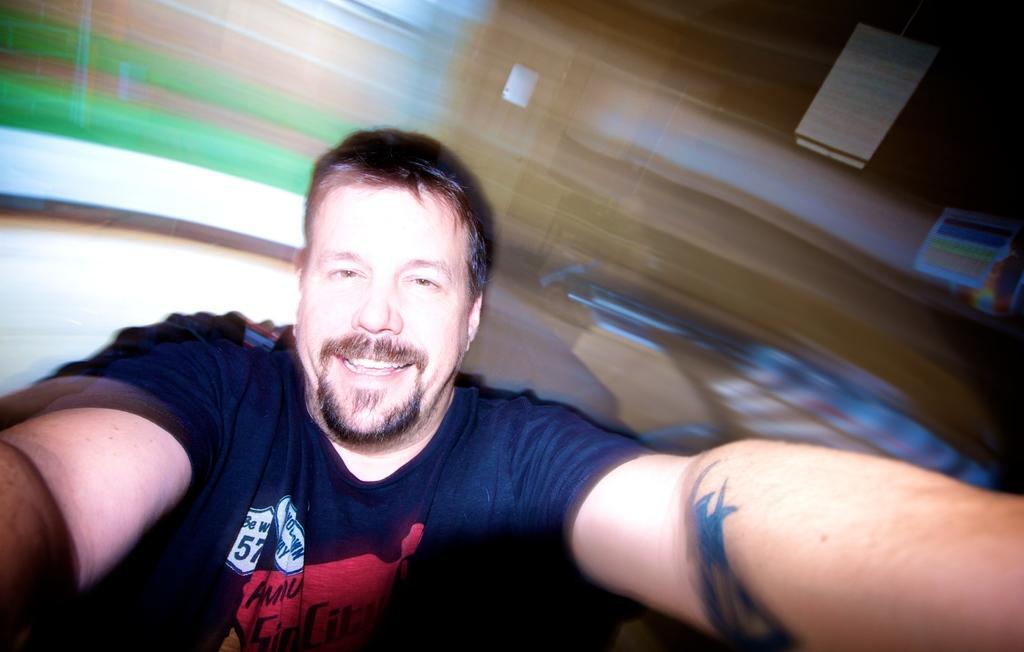Could you give a brief overview of what you see in this image? In this picture there is a man who is wearing black t-shirt. He is smiling. He is sitting near to table. On the right we can see the washbasin. In the top right corner we can see the posters. On the top left there is a window. 